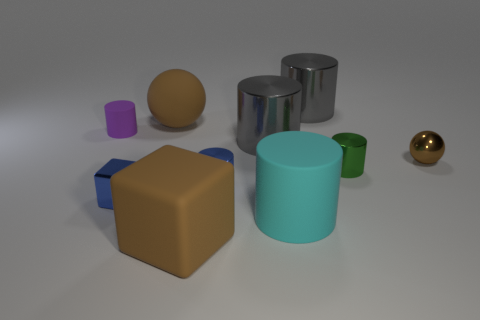Is there any other thing that is the same size as the blue metal cylinder?
Offer a very short reply. Yes. What number of things are tiny metal things or blocks?
Your answer should be very brief. 5. Are there any yellow rubber objects that have the same size as the cyan object?
Your response must be concise. No. What is the shape of the brown metal object?
Your answer should be compact. Sphere. Is the number of blue cubes that are behind the purple cylinder greater than the number of big matte objects that are behind the matte sphere?
Your answer should be very brief. No. Do the big matte thing behind the purple cylinder and the block that is behind the cyan thing have the same color?
Give a very brief answer. No. There is a cyan thing that is the same size as the brown rubber ball; what shape is it?
Provide a succinct answer. Cylinder. Is there another matte thing that has the same shape as the cyan rubber thing?
Offer a very short reply. Yes. Do the tiny thing that is behind the metal ball and the brown sphere that is behind the small purple matte thing have the same material?
Provide a short and direct response. Yes. What shape is the small thing that is the same color as the small block?
Make the answer very short. Cylinder. 